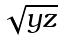<formula> <loc_0><loc_0><loc_500><loc_500>\sqrt { y z }</formula> 